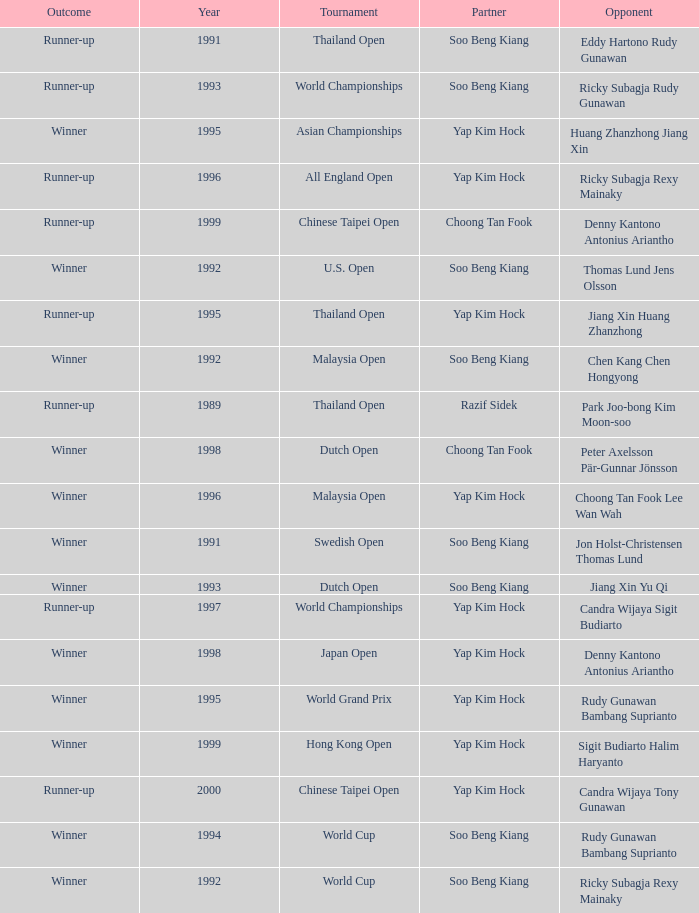Who was Choong Tan Fook's opponent in 1999? Denny Kantono Antonius Ariantho. 